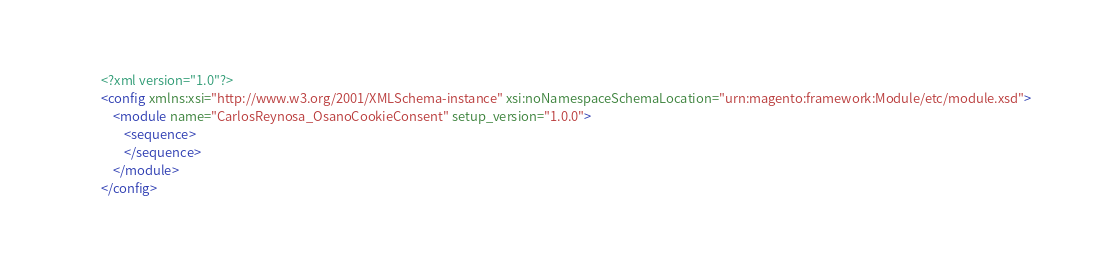Convert code to text. <code><loc_0><loc_0><loc_500><loc_500><_XML_><?xml version="1.0"?>
<config xmlns:xsi="http://www.w3.org/2001/XMLSchema-instance" xsi:noNamespaceSchemaLocation="urn:magento:framework:Module/etc/module.xsd">
    <module name="CarlosReynosa_OsanoCookieConsent" setup_version="1.0.0">
        <sequence>
        </sequence>
    </module>
</config>
</code> 